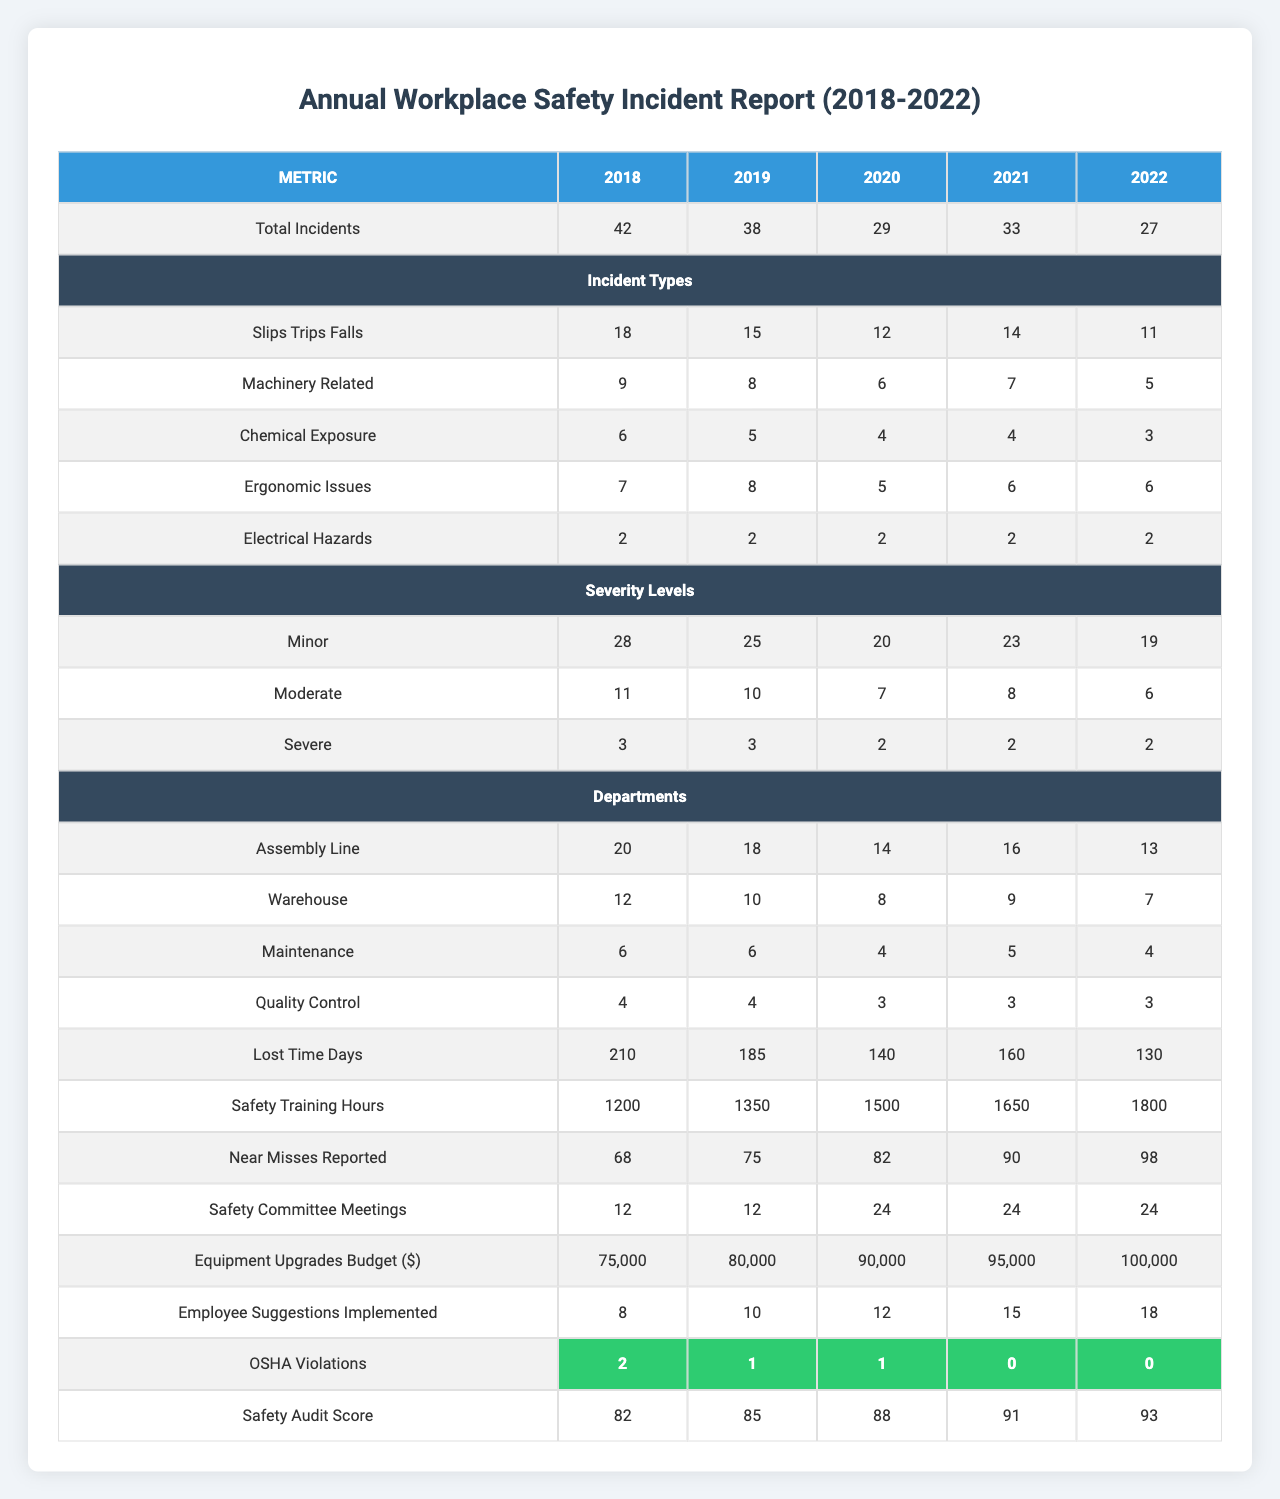What was the total number of workplace safety incidents reported in 2020? The total incidents for 2020 are given in the table under the "Total Incidents" row, which is 29.
Answer: 29 What was the trend of slips, trips, and falls incidents from 2018 to 2022? Looking at the "Slips/Trips/Falls" column, the incidents decreased from 18 in 2018 to 11 in 2022, indicating a downward trend.
Answer: Decreasing How many incidents were categorized as severe in 2021? The number of severe incidents for 2021 can be found in the "Severity Levels" section. It shows 2 severe incidents in that year.
Answer: 2 What was the total number of minor incidents across the 5 years? Summing the minor incidents from 2018 to 2022 provides the total: 28 + 25 + 20 + 23 + 19 = 115.
Answer: 115 In which department were the most incidents reported in 2022? The "Departments" section shows that the most incidents were reported in the "Assembly Line" with 13 incidents in 2022.
Answer: Assembly Line How many lost time days were recorded in 2019? Referring to the "Lost Time Days" row, it shows 185 days lost in 2019.
Answer: 185 Was the OSHA violations count ever zero in the given years? The table shows that the OSHA violations were 0 in 2021 and 2022.
Answer: Yes What is the percentage decrease in total incidents from 2018 to 2022? The decrease in total incidents is calculated as (42 - 27) / 42 * 100, which yields approximately 35.71%.
Answer: ~35.71% How many more safety training hours were conducted in 2022 compared to 2018? The training hours in 2022 were 1800, and in 2018, they were 1200. The difference is 1800 - 1200 = 600 hours.
Answer: 600 Which year had the highest number of near misses reported? By checking the "Near Misses Reported" row, 98 near misses were reported in 2022 which is the highest compared to the previous years.
Answer: 2022 What was the overall trend in the safety audit score from 2018 to 2022? The safety audit score increased from 82 in 2018 to 93 in 2022, showing an upward trend over the 5 years.
Answer: Increasing How much did the equipment upgrades budget increase from 2018 to 2022? The budget increased from $75,000 in 2018 to $100,000 in 2022, which is a difference of $25,000.
Answer: $25,000 Was there any year where the number of employee suggestions implemented was less than 10? Looking at the "Employee Suggestions Implemented" row, 8 were implemented in 2018, which is less than 10.
Answer: Yes What is the average number of machinery-related incidents over the 5 years? The total machinery-related incidents are 9 + 8 + 6 + 7 + 5 = 35. Dividing by 5 gives an average of 7 incidents.
Answer: 7 In which year was the highest number of safety committee meetings held? The table shows that 24 safety committee meetings were held in 2021 and 2022, which is the highest.
Answer: 2021 and 2022 